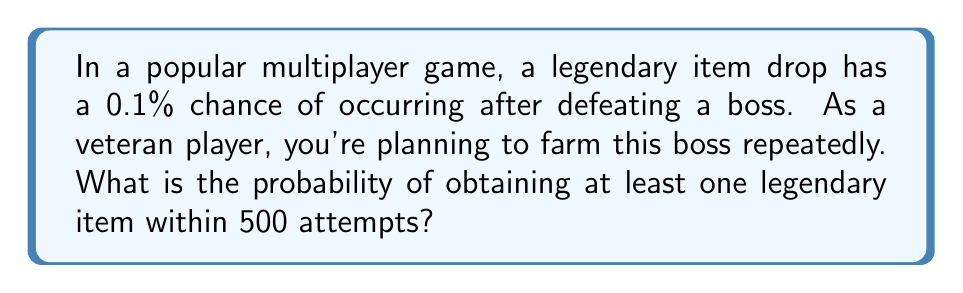Teach me how to tackle this problem. Let's approach this step-by-step:

1) First, we need to calculate the probability of not getting the legendary item in a single attempt:
   $P(\text{no legendary}) = 1 - 0.001 = 0.999$ or $99.9\%$

2) Now, we need to find the probability of not getting the legendary item in all 500 attempts:
   $P(\text{no legendary in 500 attempts}) = (0.999)^{500}$

3) We can calculate this using logarithms:
   $\log(0.999^{500}) = 500 \times \log(0.999) \approx -0.5005$
   $0.999^{500} \approx 10^{-0.5005} \approx 0.3161$

4) This means the probability of not getting the legendary item in 500 attempts is about 0.3161 or 31.61%

5) Therefore, the probability of getting at least one legendary item in 500 attempts is:
   $P(\text{at least one legendary}) = 1 - P(\text{no legendary in 500 attempts})$
   $= 1 - 0.3161 \approx 0.6839$ or $68.39\%$
Answer: $\approx 68.39\%$ 